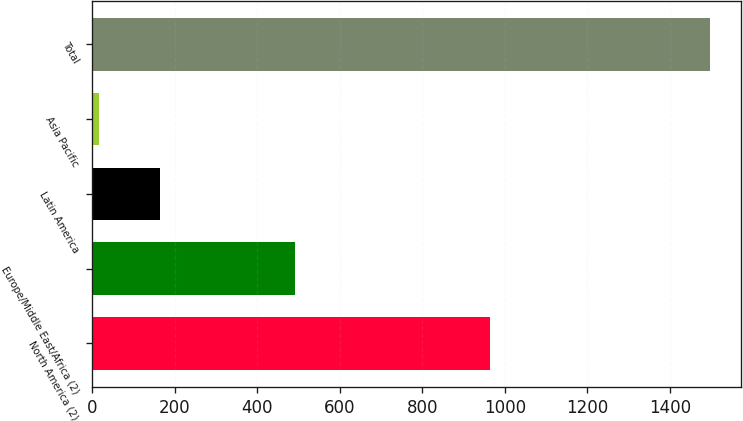Convert chart to OTSL. <chart><loc_0><loc_0><loc_500><loc_500><bar_chart><fcel>North America (2)<fcel>Europe/Middle East/Africa (2)<fcel>Latin America<fcel>Asia Pacific<fcel>Total<nl><fcel>964.9<fcel>492.7<fcel>164.27<fcel>16.2<fcel>1496.9<nl></chart> 